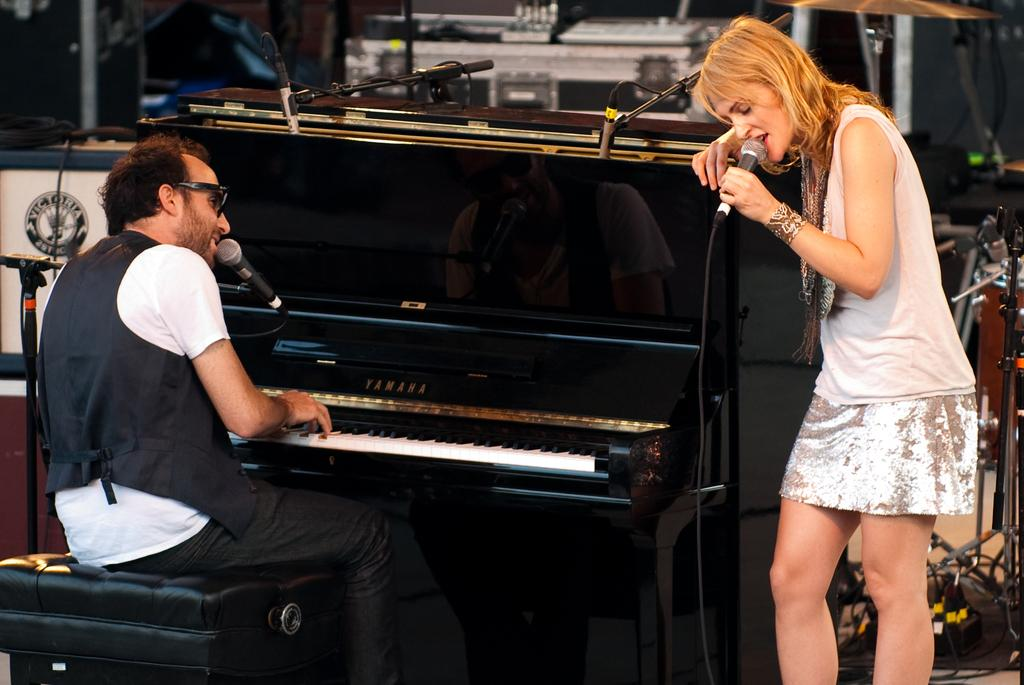How many people are present in the image? There are two people in the image, a man and a woman. What are the man and woman doing in the image? Both the man and woman are singing, and the man is playing a piano. What can be seen on the man's face in the image? The man is wearing spectacles in the image. What type of furniture is present in the image? There is a chair in the image. What else can be seen in the image besides the people and furniture? There are cables visible in the image. What is the surface that the people and furniture are placed on in the image? There is a floor in the image. What type of rose is the man holding in the image? There is no rose present in the image; the man is playing a piano and singing. Can you tell me how many dinosaurs are visible in the image? There are no dinosaurs present in the image; it features a man playing a piano, a woman singing, and various other elements. What type of quartz can be seen in the image? There is no quartz present in the image. 